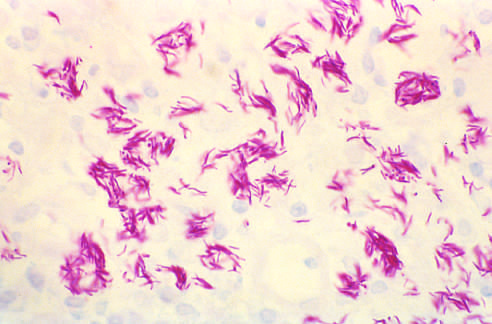what shows massive intracellular macrophage infection with acid-fast organisms (filamentous and pink in this acid-fast stain preparation)?
Answer the question using a single word or phrase. Mycobacterium avium infection 